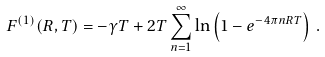<formula> <loc_0><loc_0><loc_500><loc_500>F ^ { ( 1 ) } ( R , T ) = - \gamma T + 2 T \sum _ { n = 1 } ^ { \infty } \ln \left ( 1 - e ^ { - 4 \pi n R T } \right ) \, { . }</formula> 